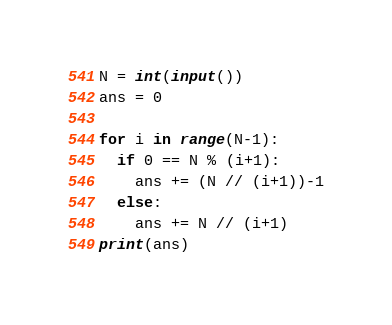Convert code to text. <code><loc_0><loc_0><loc_500><loc_500><_Python_>N = int(input())
ans = 0

for i in range(N-1):
  if 0 == N % (i+1):
    ans += (N // (i+1))-1
  else:  
    ans += N // (i+1)
print(ans)</code> 